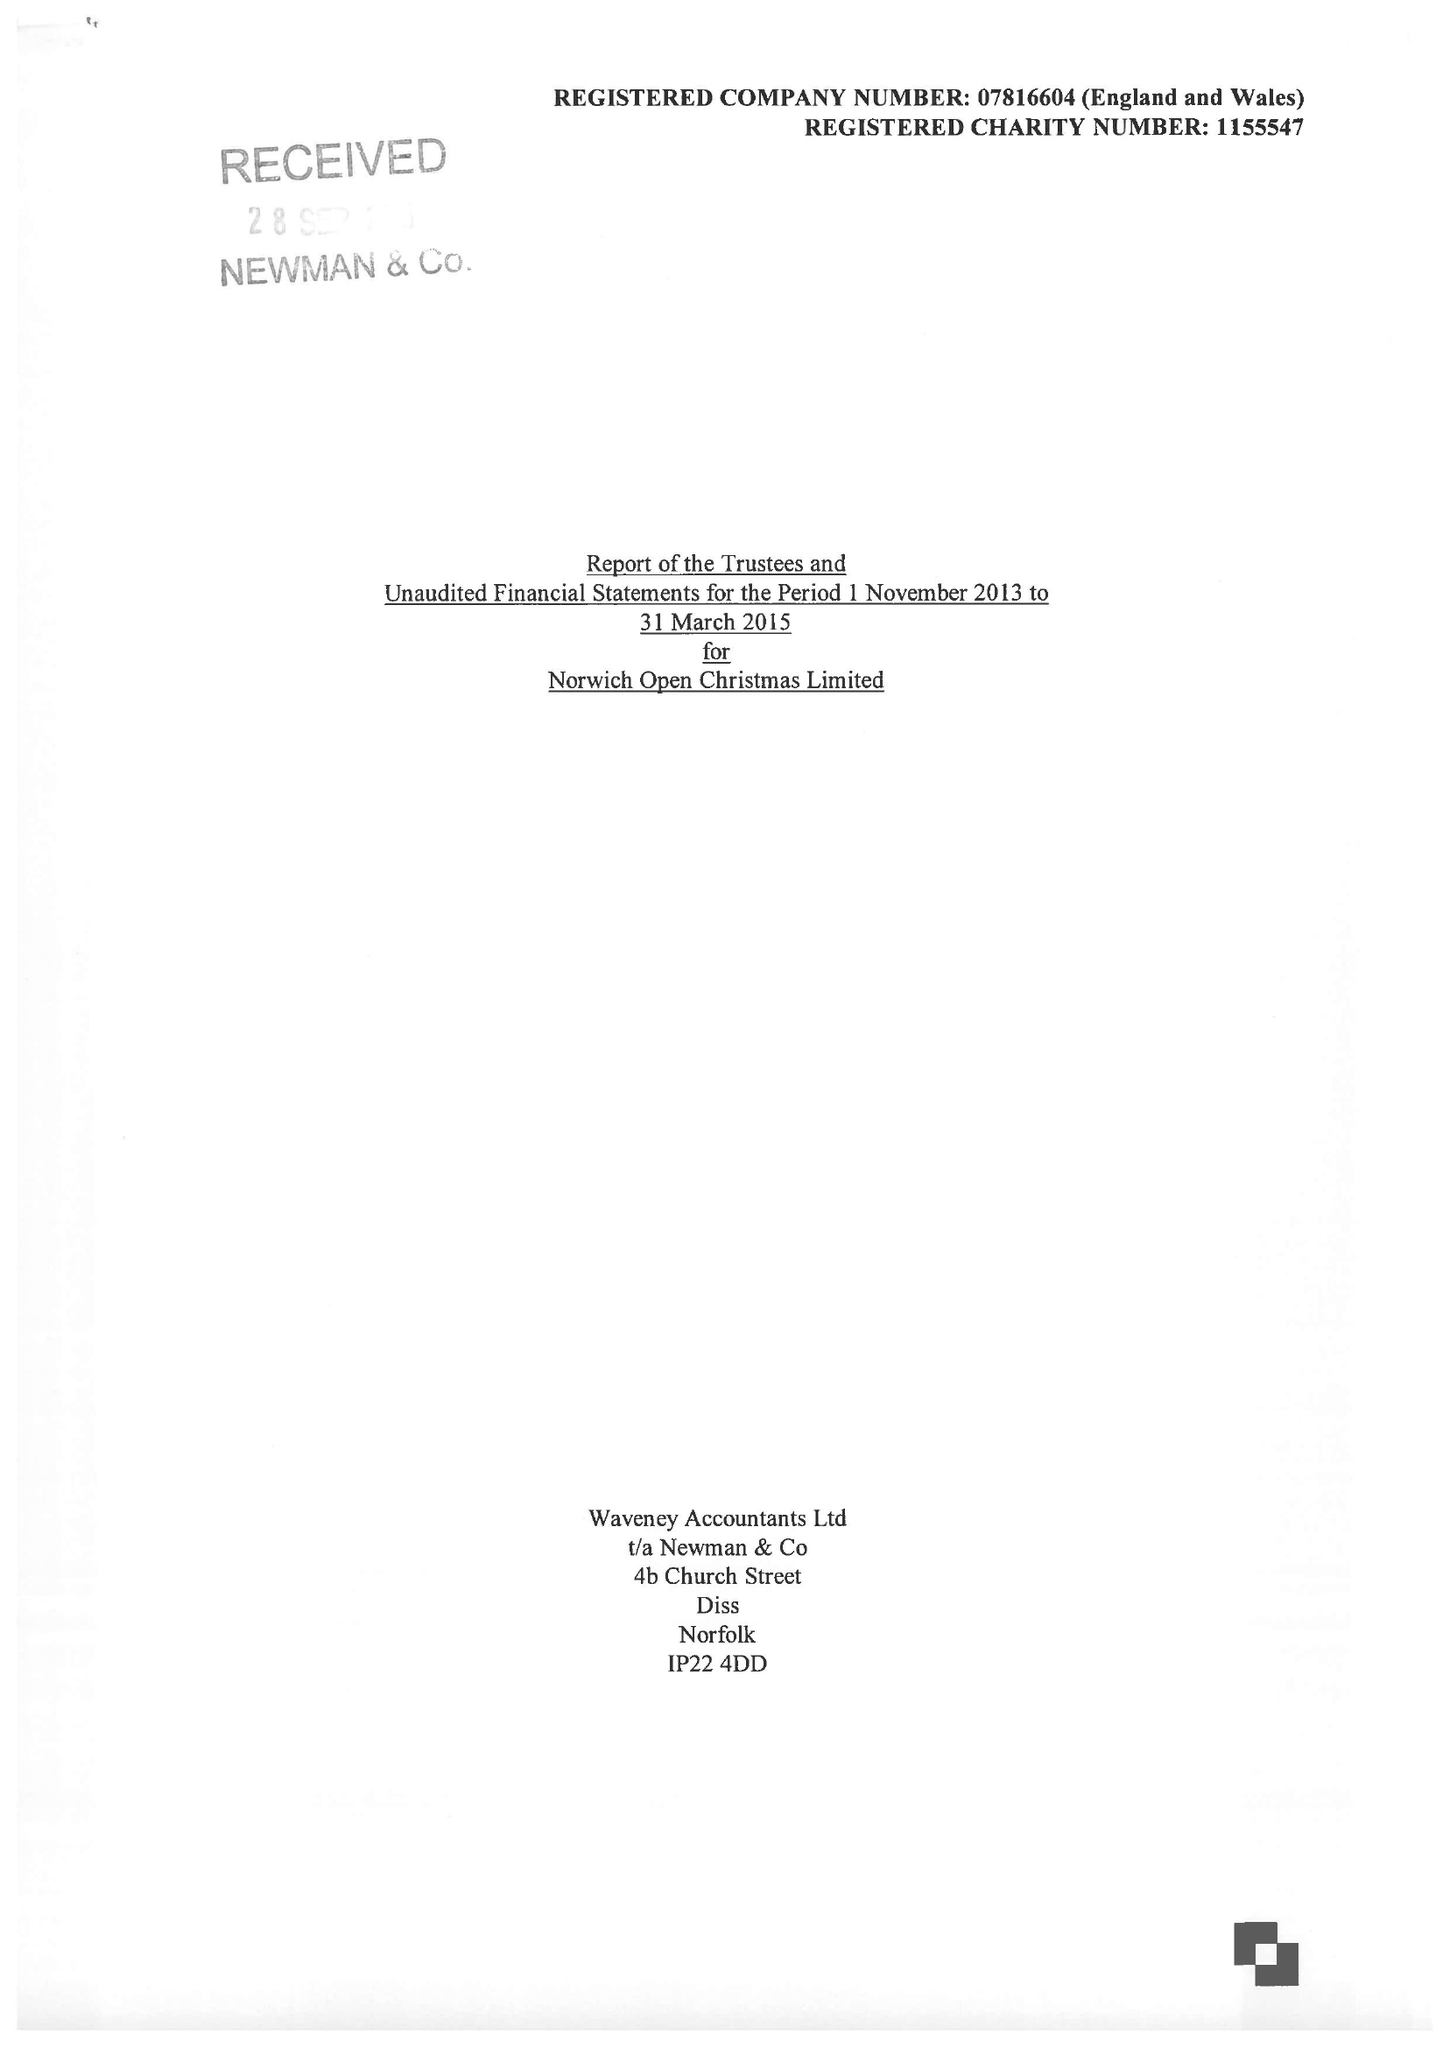What is the value for the report_date?
Answer the question using a single word or phrase. 2015-03-31 